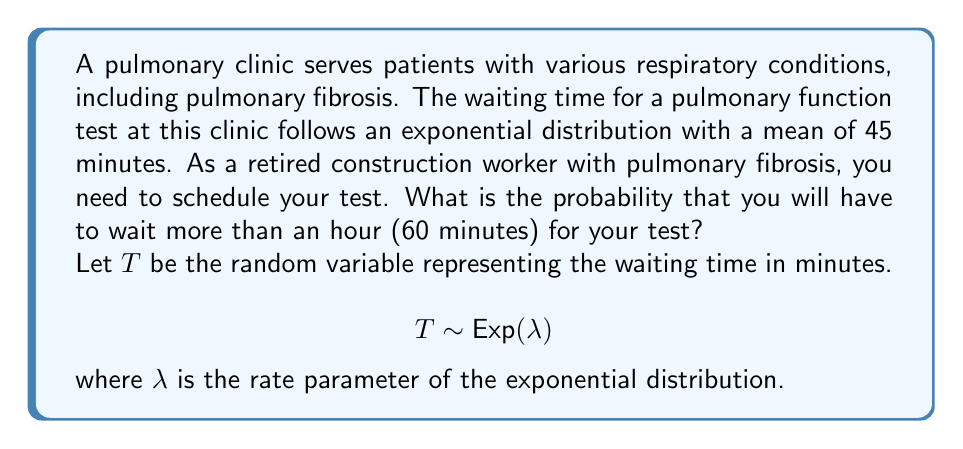Can you answer this question? To solve this problem, we'll follow these steps:

1) First, we need to find the rate parameter $\lambda$ of the exponential distribution. Given that the mean waiting time is 45 minutes, we can use the property that for an exponential distribution:

   $$E[T] = \frac{1}{\lambda}$$

   Therefore, $\lambda = \frac{1}{45}$

2) Now, we want to find $P(T > 60)$. For an exponential distribution:

   $$P(T > t) = e^{-\lambda t}$$

3) Substituting our values:

   $$P(T > 60) = e^{-\frac{1}{45} \cdot 60}$$

4) Simplifying:

   $$P(T > 60) = e^{-\frac{4}{3}} \approx 0.2636$$

5) Converting to a percentage:

   $0.2636 \times 100\% \approx 26.36\%$

Therefore, the probability of waiting more than an hour for your pulmonary function test is approximately 26.36%.
Answer: $26.36\%$ 